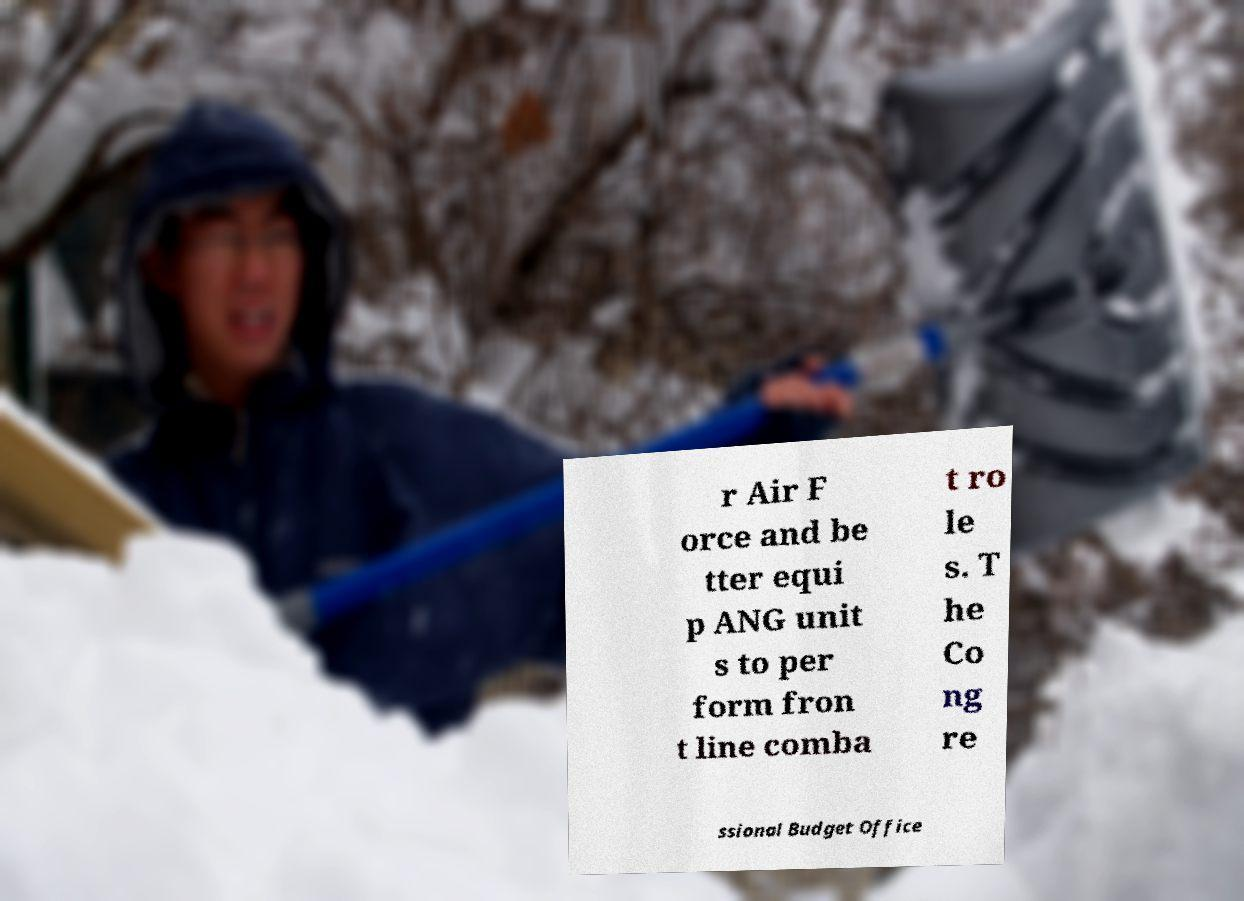I need the written content from this picture converted into text. Can you do that? r Air F orce and be tter equi p ANG unit s to per form fron t line comba t ro le s. T he Co ng re ssional Budget Office 